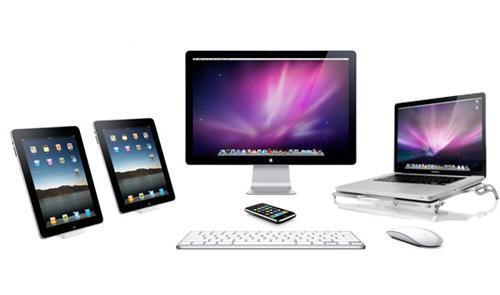How many laptops are there?
Give a very brief answer. 1. How many tablets are there?
Give a very brief answer. 2. 